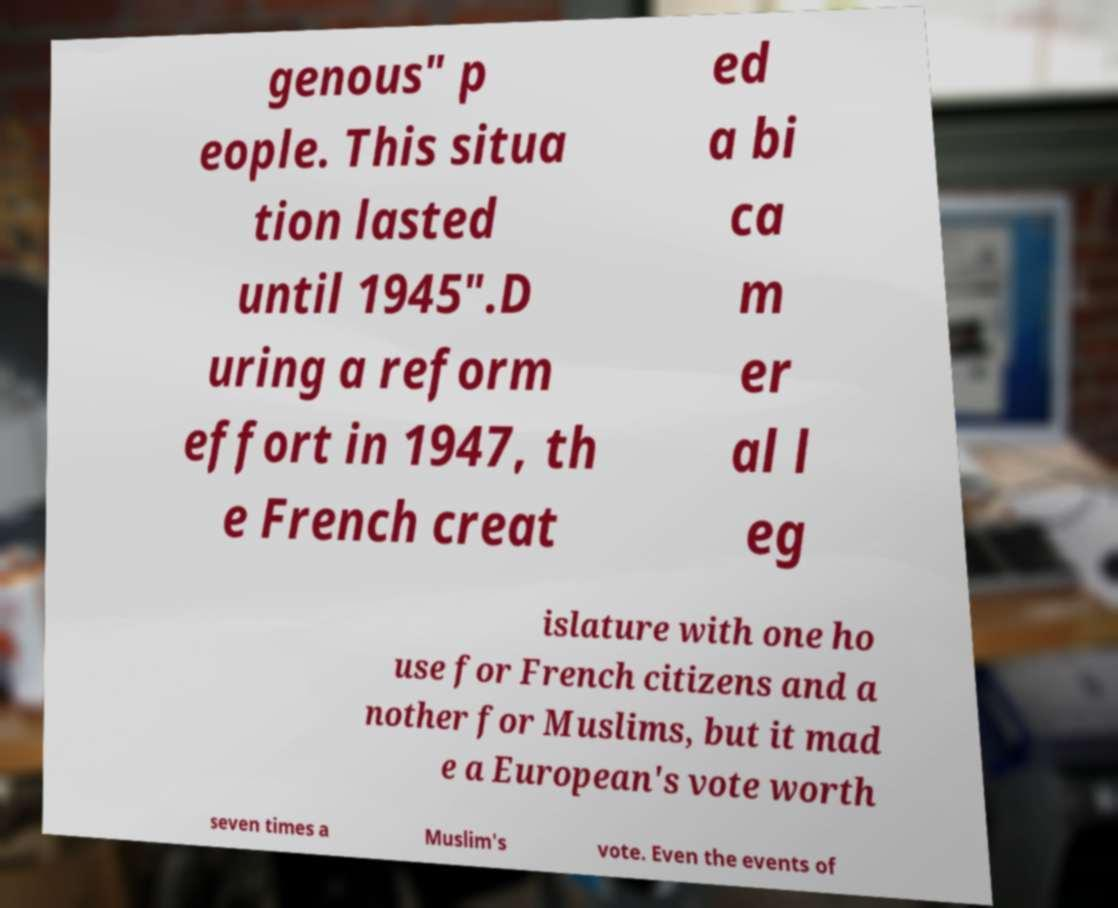What messages or text are displayed in this image? I need them in a readable, typed format. genous" p eople. This situa tion lasted until 1945".D uring a reform effort in 1947, th e French creat ed a bi ca m er al l eg islature with one ho use for French citizens and a nother for Muslims, but it mad e a European's vote worth seven times a Muslim's vote. Even the events of 